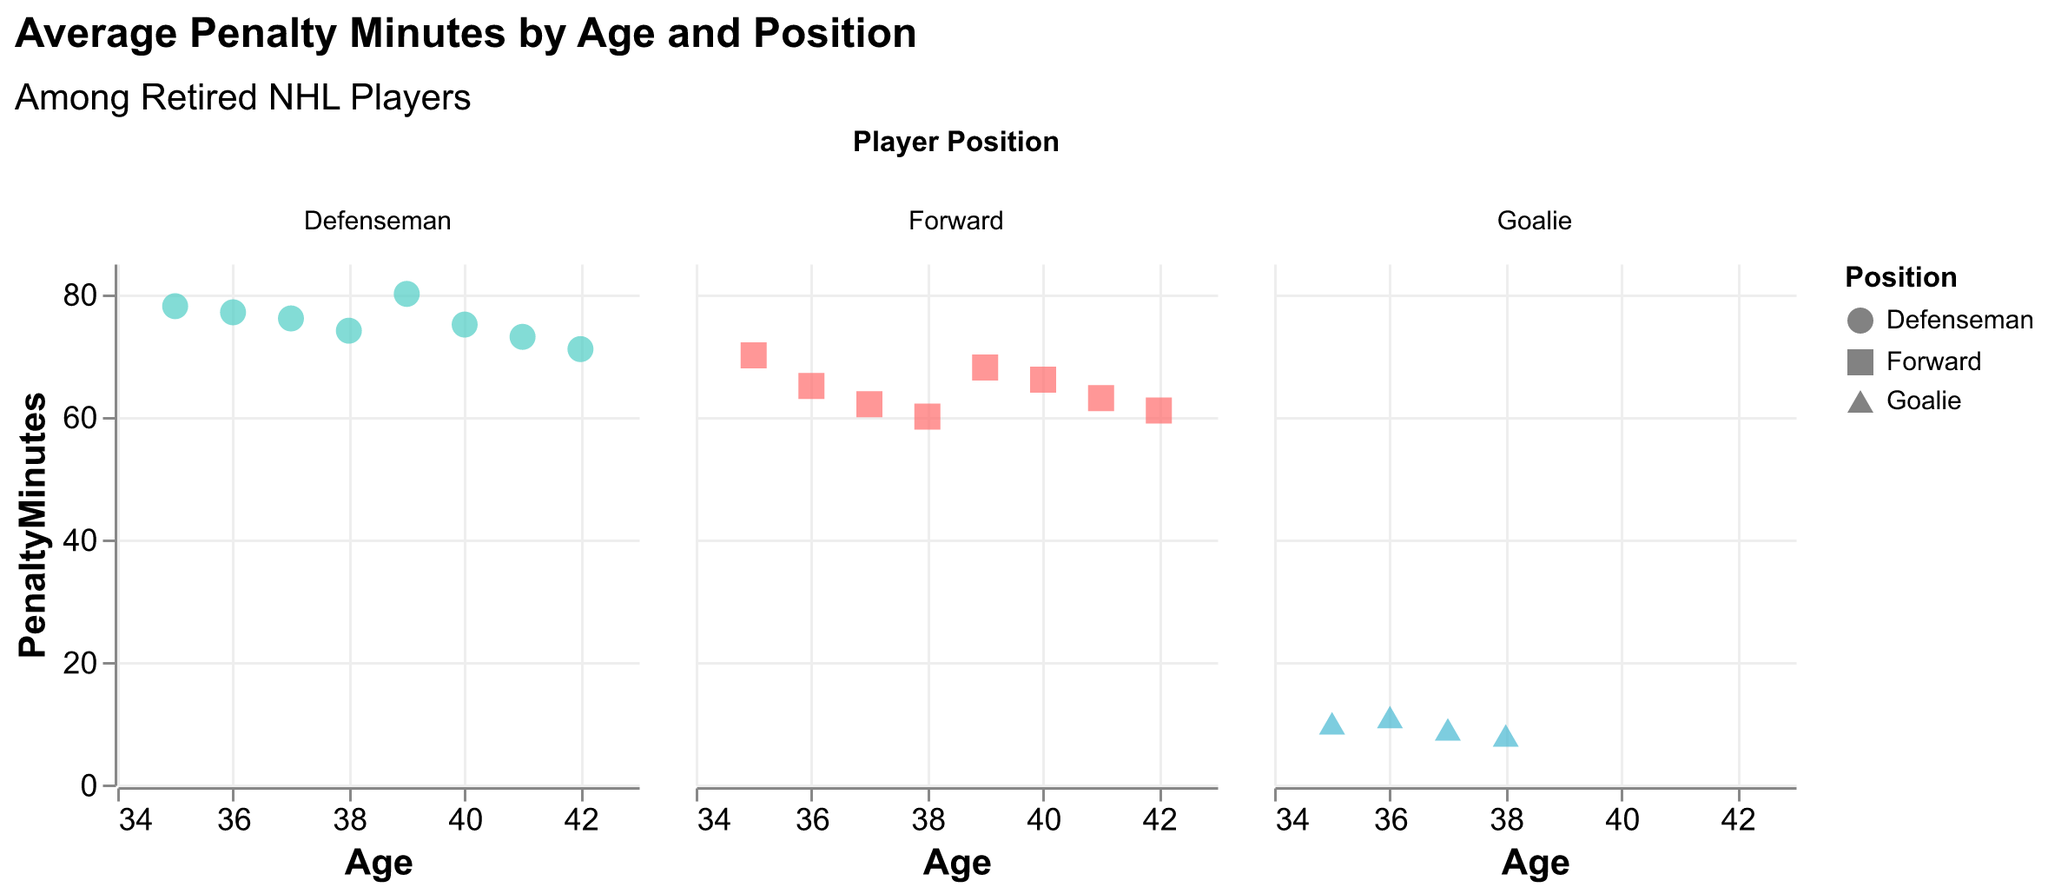How many positions are displayed in the figure? There are three distinct positions shown in the figure: Forward, Defenseman, and Goalie.
Answer: Three What does the x-axis represent? The x-axis represents the age of the retired NHL players.
Answer: Age What is the highest value of penalty minutes for a Defenseman at age 39? Looking at the subplot for Defensemen, the data point at age 39 indicates a penalty minutes value of 80.
Answer: 80 Which position has the least average penalty minutes across all ages? A quick comparison of the plots shows that Goalies consistently have the lowest penalty minutes values in their subplot.
Answer: Goalie How do the penalty minutes for Forwards change with age? Analyzing the Forwards subplot, it shows that penalty minutes generally decrease as age increases.
Answer: Decrease Compare the penalty minutes of Defensemen at ages 35 and 42. Which age has higher penalty minutes? At age 35, Defensemen have penalty minutes of 78 and at age 42, it is 71. Therefore, age 35 has higher penalty minutes.
Answer: Age 35 What is the color used for Forwards in the figure? The color used for Forwards in the figure is red.
Answer: Red Between ages 37 and 40, which position shows the most variability in penalty minutes? By observing the subplots closely, Defensemen show the most variability between ages 37 and 40, with values ranging from 74 to 76.
Answer: Defenseman Is there any age where Goalies have more penalty minutes than Forwards? At all ages shown (35-42), Goalies consistently have fewer penalty minutes than Forwards.
Answer: No Summarize the general trend of penalty minutes for Defensemen with increasing age from 35 to 42. The penalty minutes for Defensemen generally decrease with age, starting at a high of 78 at age 35 and ending at 71 at age 42.
Answer: Decrease 